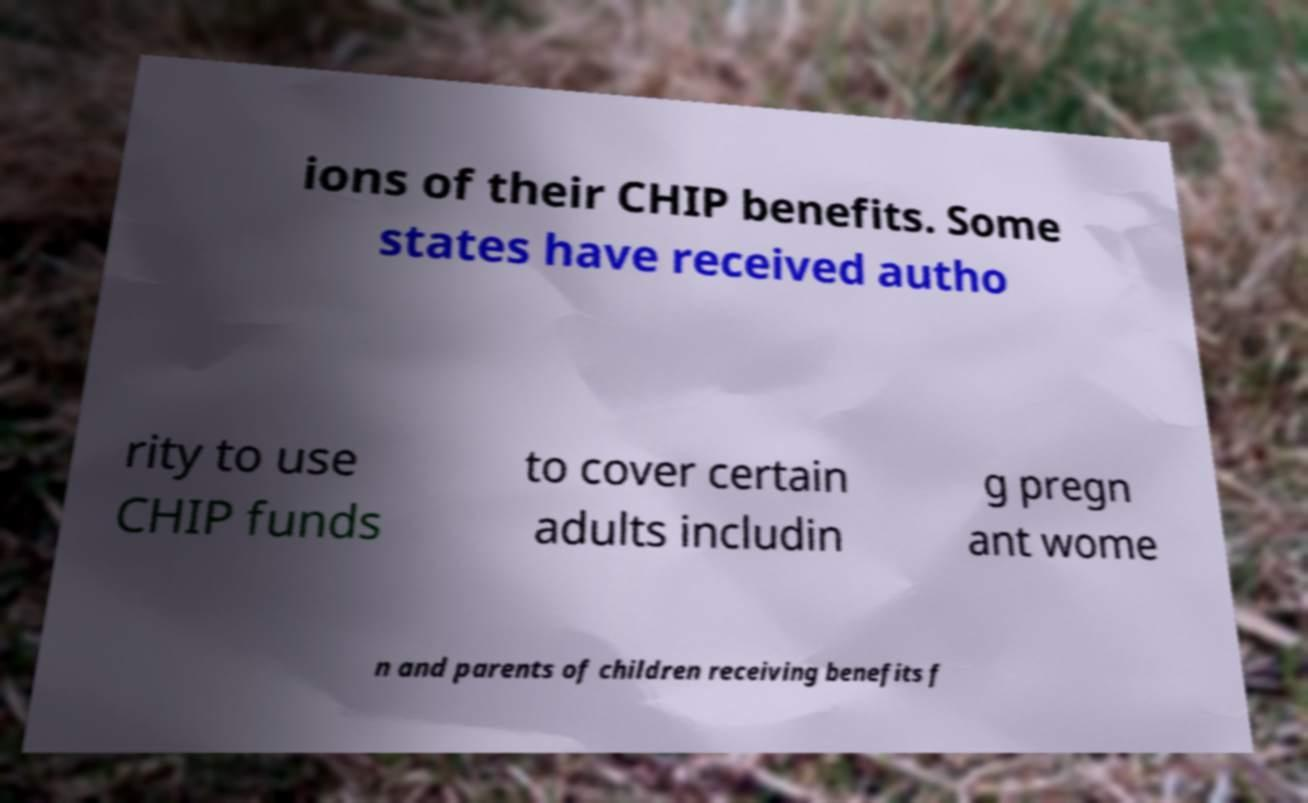What messages or text are displayed in this image? I need them in a readable, typed format. ions of their CHIP benefits. Some states have received autho rity to use CHIP funds to cover certain adults includin g pregn ant wome n and parents of children receiving benefits f 